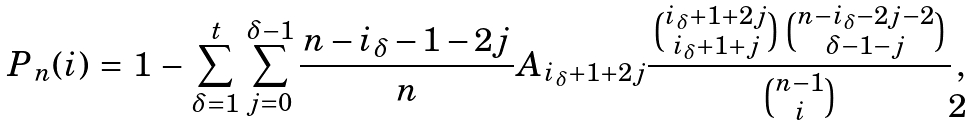<formula> <loc_0><loc_0><loc_500><loc_500>\, P _ { \, n } ( i ) & \, = \, 1 \, - \, \sum _ { \delta = 1 } ^ { t } \, \sum _ { j = 0 } ^ { \delta - 1 } { \frac { \, n - i _ { \delta } - 1 - 2 j \, } { n } } A _ { i _ { \delta } + 1 + 2 j } \frac { \, \binom { i _ { \delta } + 1 + 2 j } { i _ { \delta } + 1 + j } \, \binom { n - i _ { \delta } - 2 j - 2 } { \delta - 1 - j } \, } { \binom { n - 1 } { i } } \, , \,</formula> 